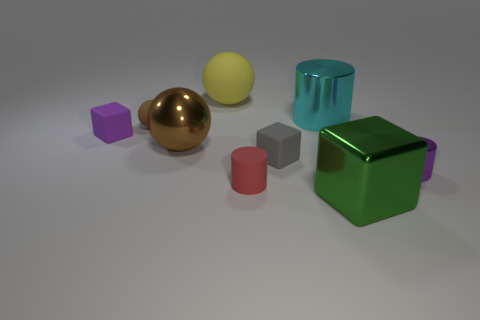Subtract all tiny cylinders. How many cylinders are left? 1 Subtract all yellow spheres. How many spheres are left? 2 Subtract all spheres. How many objects are left? 6 Add 8 brown balls. How many brown balls are left? 10 Add 7 big green cubes. How many big green cubes exist? 8 Add 1 red matte cylinders. How many objects exist? 10 Subtract 0 gray balls. How many objects are left? 9 Subtract 1 cylinders. How many cylinders are left? 2 Subtract all yellow cubes. Subtract all brown balls. How many cubes are left? 3 Subtract all brown spheres. How many green cubes are left? 1 